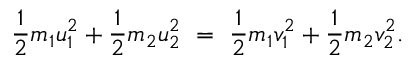Convert formula to latex. <formula><loc_0><loc_0><loc_500><loc_500>{ \frac { 1 } { 2 } } m _ { 1 } u _ { 1 } ^ { 2 } + { \frac { 1 } { 2 } } m _ { 2 } u _ { 2 } ^ { 2 } \ = \ { \frac { 1 } { 2 } } m _ { 1 } v _ { 1 } ^ { 2 } + { \frac { 1 } { 2 } } m _ { 2 } v _ { 2 } ^ { 2 } .</formula> 